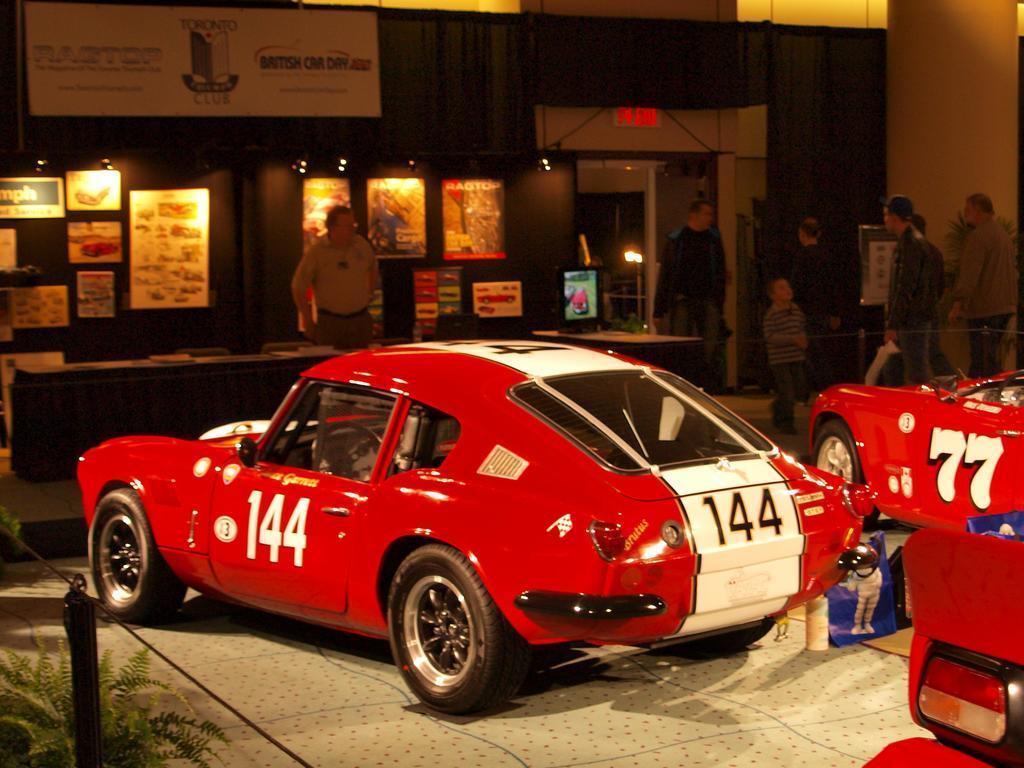Please provide a concise description of this image. There are two cars present at the bottom of this image, and there is one person standing in the middle of this image, and there are some persons standing on the right side of this image. There is a wall in the background. We can see there are some boards attached to it. There is a plant in the bottom left corner of this image. 